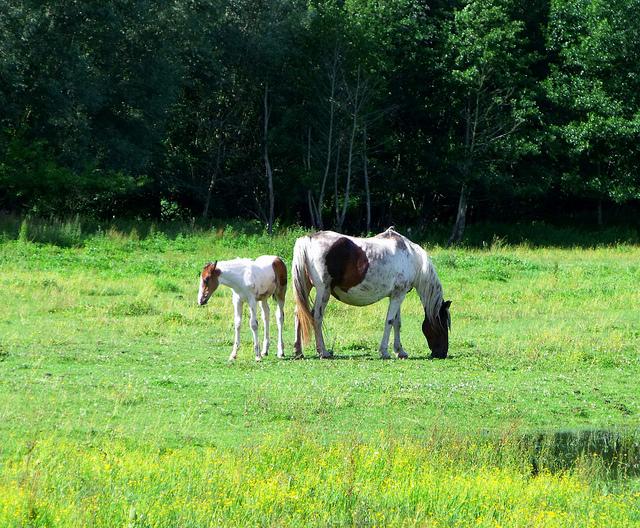What is the big horse doing?
Be succinct. Eating. What is next to the horse?
Keep it brief. Foal. Which horse is older?
Concise answer only. Right one. 